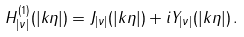Convert formula to latex. <formula><loc_0><loc_0><loc_500><loc_500>H _ { | \nu | } ^ { ( 1 ) } ( | k \eta | ) = J _ { | \nu | } ( | k \eta | ) + i Y _ { | \nu | } ( | k \eta | ) \, .</formula> 